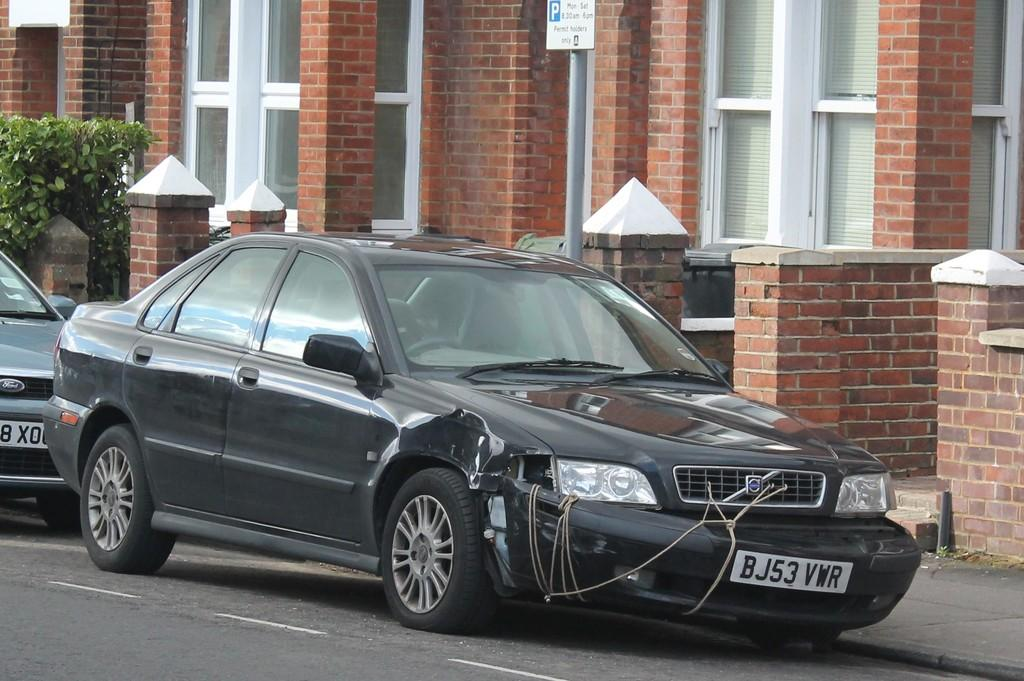Provide a one-sentence caption for the provided image. a black car with the letter B on the license plate. 